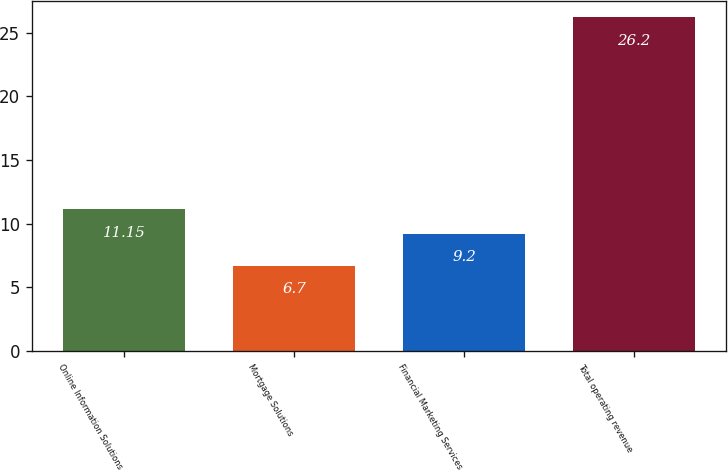Convert chart to OTSL. <chart><loc_0><loc_0><loc_500><loc_500><bar_chart><fcel>Online Information Solutions<fcel>Mortgage Solutions<fcel>Financial Marketing Services<fcel>Total operating revenue<nl><fcel>11.15<fcel>6.7<fcel>9.2<fcel>26.2<nl></chart> 